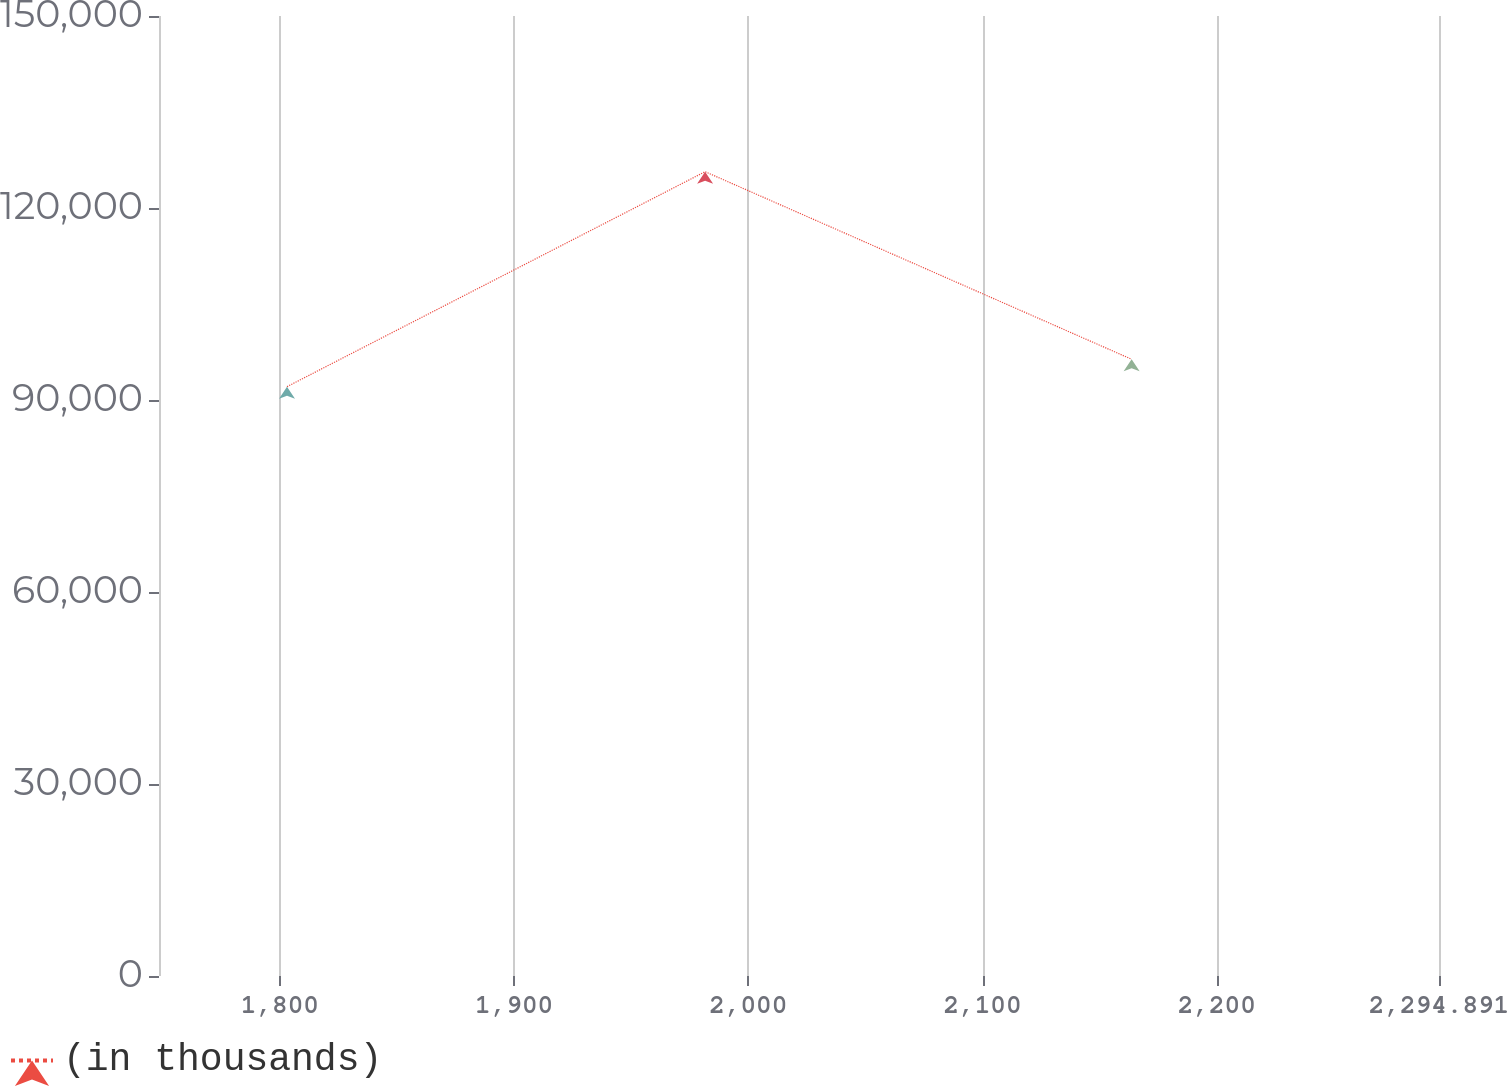<chart> <loc_0><loc_0><loc_500><loc_500><line_chart><ecel><fcel>(in thousands)<nl><fcel>1803.05<fcel>92083.1<nl><fcel>1981.56<fcel>125675<nl><fcel>2163.66<fcel>96364.3<nl><fcel>2295.66<fcel>103633<nl><fcel>2349.54<fcel>88350.7<nl></chart> 